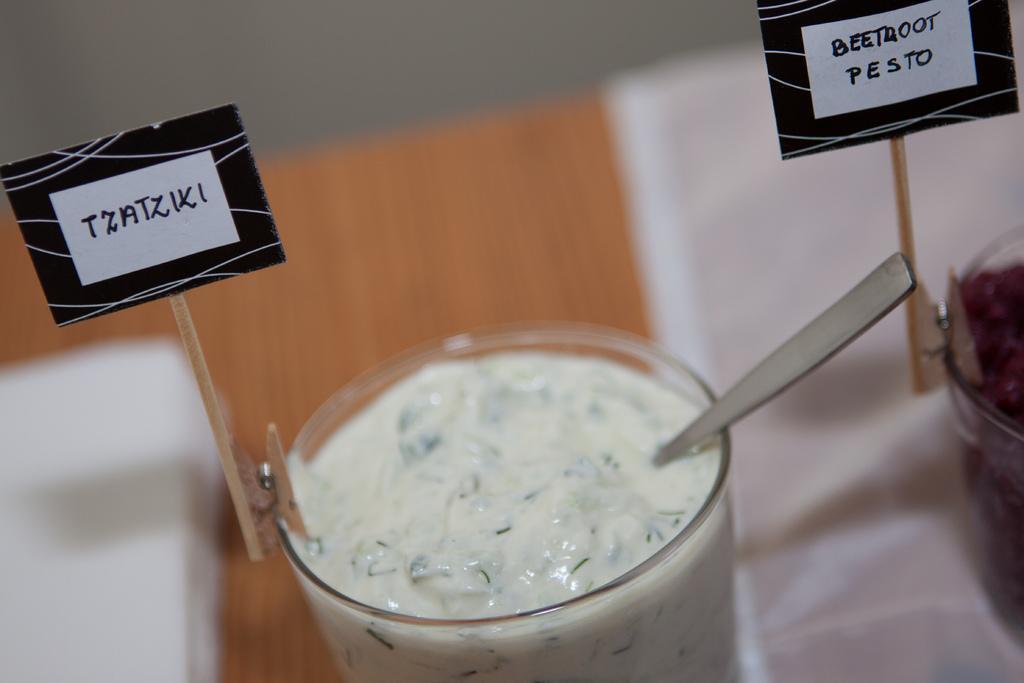Could you give a brief overview of what you see in this image? At the top of the image there is a wall. In the middle of the image there is a table with two glasses of desserts and spoons on the table. There are two name boards on the table. 